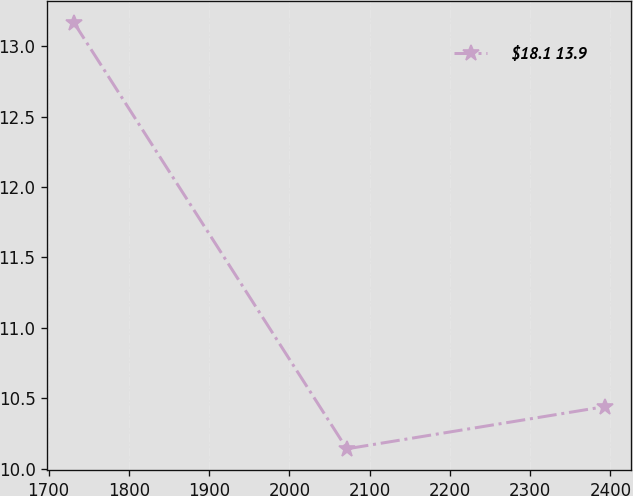<chart> <loc_0><loc_0><loc_500><loc_500><line_chart><ecel><fcel>$18.1 13.9<nl><fcel>1731.41<fcel>13.17<nl><fcel>2071.56<fcel>10.14<nl><fcel>2392.91<fcel>10.44<nl></chart> 